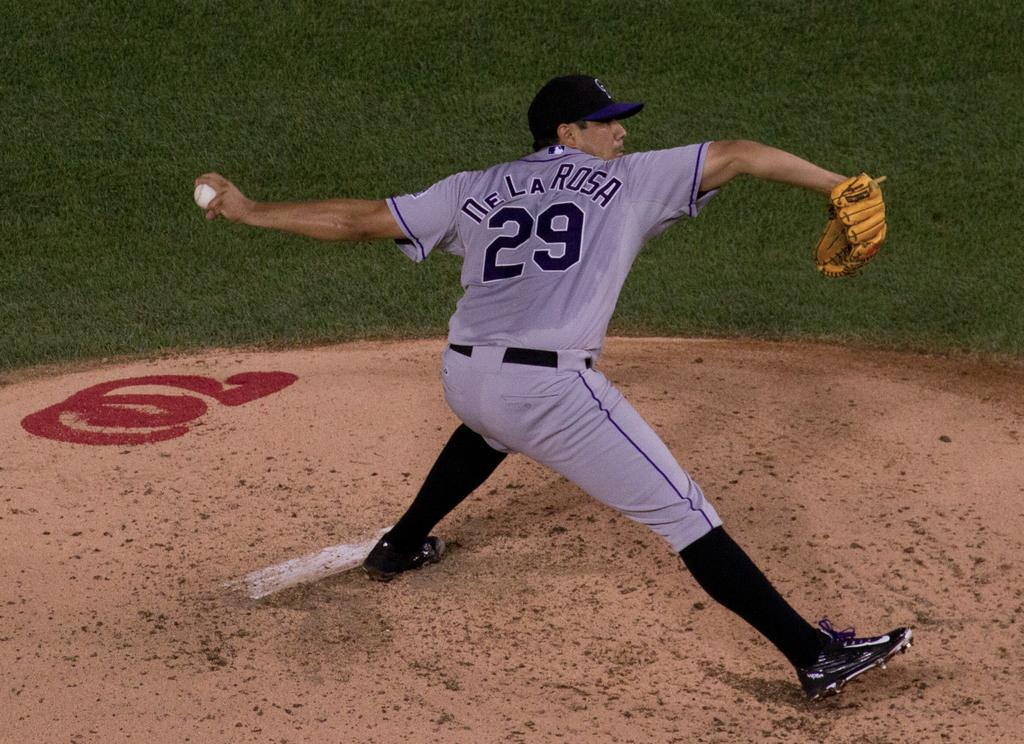<image>
Render a clear and concise summary of the photo. ptitcher in gray, number 29 de la rosa, getting ready to throw the ball 